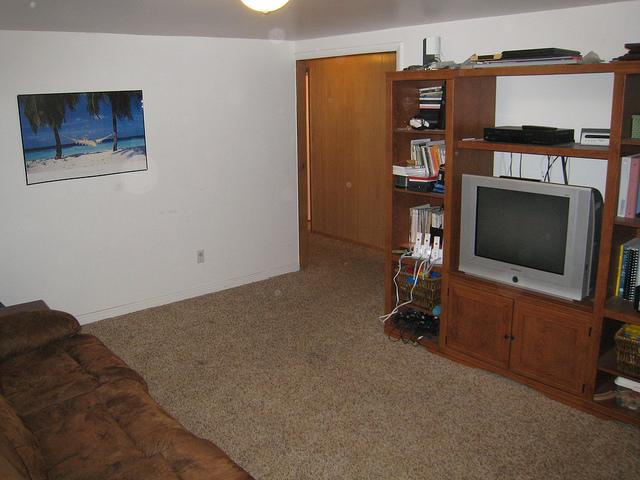What is the print on the wall depicting?
Be succinct. Beach. Is the television on or off?
Keep it brief. Off. Is that a tube tv?
Write a very short answer. Yes. Does this room have crown molding in the door frames?
Keep it brief. Yes. What is on the wall?
Keep it brief. Picture. What is the object in front of the couch?
Be succinct. Tv. How is the room?
Concise answer only. Clean. What tall item can be seen straight ahead through the door frame?
Concise answer only. Closet. What are the walls made of?
Give a very brief answer. Sheetrock. How many pictures are on the wall?
Write a very short answer. 1. What color is the couch?
Give a very brief answer. Brown. What color are the walls?
Give a very brief answer. White. Is the TV on or off?
Concise answer only. Off. 